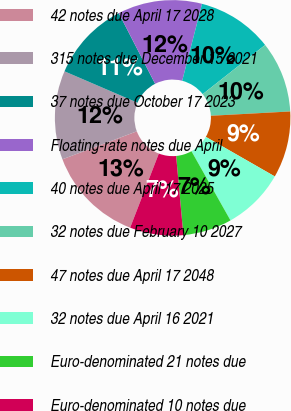Convert chart. <chart><loc_0><loc_0><loc_500><loc_500><pie_chart><fcel>42 notes due April 17 2028<fcel>315 notes due December 15 2021<fcel>37 notes due October 17 2023<fcel>Floating-rate notes due April<fcel>40 notes due April 17 2025<fcel>32 notes due February 10 2027<fcel>47 notes due April 17 2048<fcel>32 notes due April 16 2021<fcel>Euro-denominated 21 notes due<fcel>Euro-denominated 10 notes due<nl><fcel>13.4%<fcel>12.19%<fcel>10.97%<fcel>11.58%<fcel>10.36%<fcel>9.76%<fcel>9.15%<fcel>8.54%<fcel>6.72%<fcel>7.33%<nl></chart> 